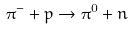<formula> <loc_0><loc_0><loc_500><loc_500>\pi ^ { - } + p \rightarrow \pi ^ { 0 } + n</formula> 